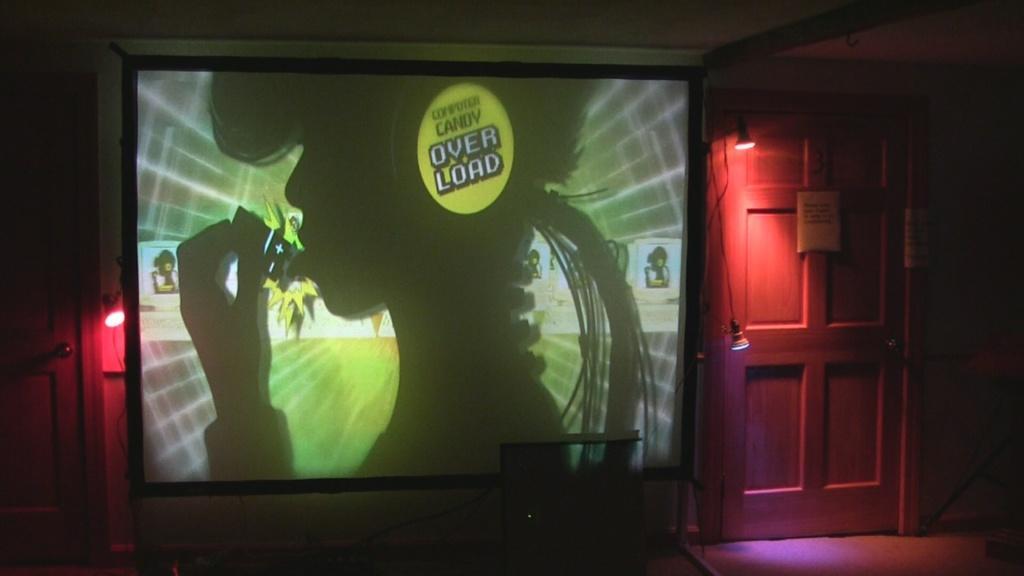Can you describe this image briefly? This image is a taken indoors. At the top of the image there is a ceiling. At the bottom of the image there is a floor. In the middle of the image there is a screen with an image and a text on it and there is a wall. There are a few lights. On the right side of the image there is a door. 